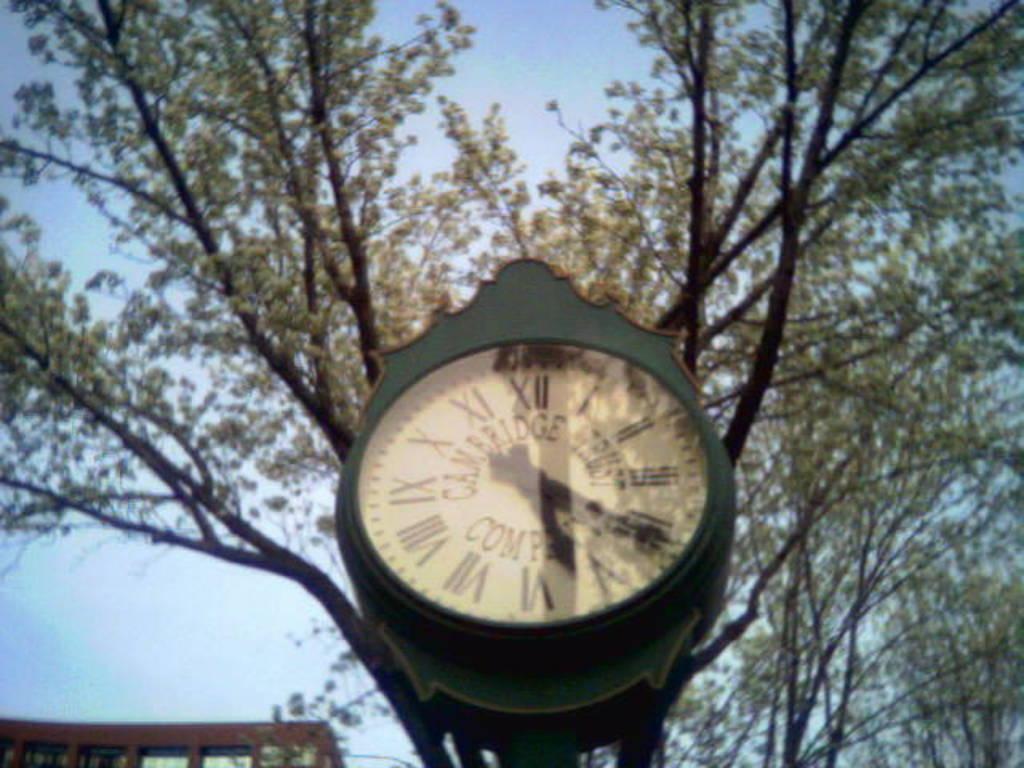What company made the clock in the photo?
Your answer should be very brief. Cambridge trust company. 